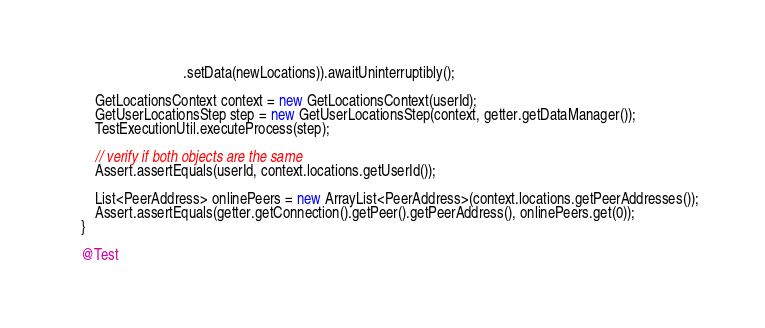Convert code to text. <code><loc_0><loc_0><loc_500><loc_500><_Java_>								.setData(newLocations)).awaitUninterruptibly();

		GetLocationsContext context = new GetLocationsContext(userId);
		GetUserLocationsStep step = new GetUserLocationsStep(context, getter.getDataManager());
		TestExecutionUtil.executeProcess(step);

		// verify if both objects are the same
		Assert.assertEquals(userId, context.locations.getUserId());

		List<PeerAddress> onlinePeers = new ArrayList<PeerAddress>(context.locations.getPeerAddresses());
		Assert.assertEquals(getter.getConnection().getPeer().getPeerAddress(), onlinePeers.get(0));
	}

	@Test</code> 